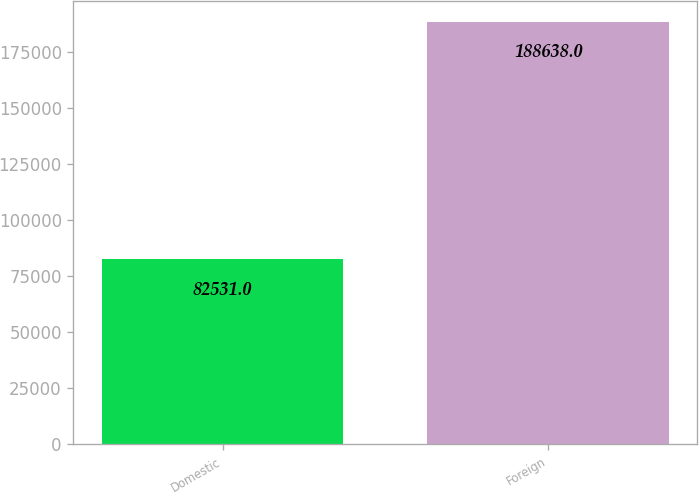Convert chart. <chart><loc_0><loc_0><loc_500><loc_500><bar_chart><fcel>Domestic<fcel>Foreign<nl><fcel>82531<fcel>188638<nl></chart> 